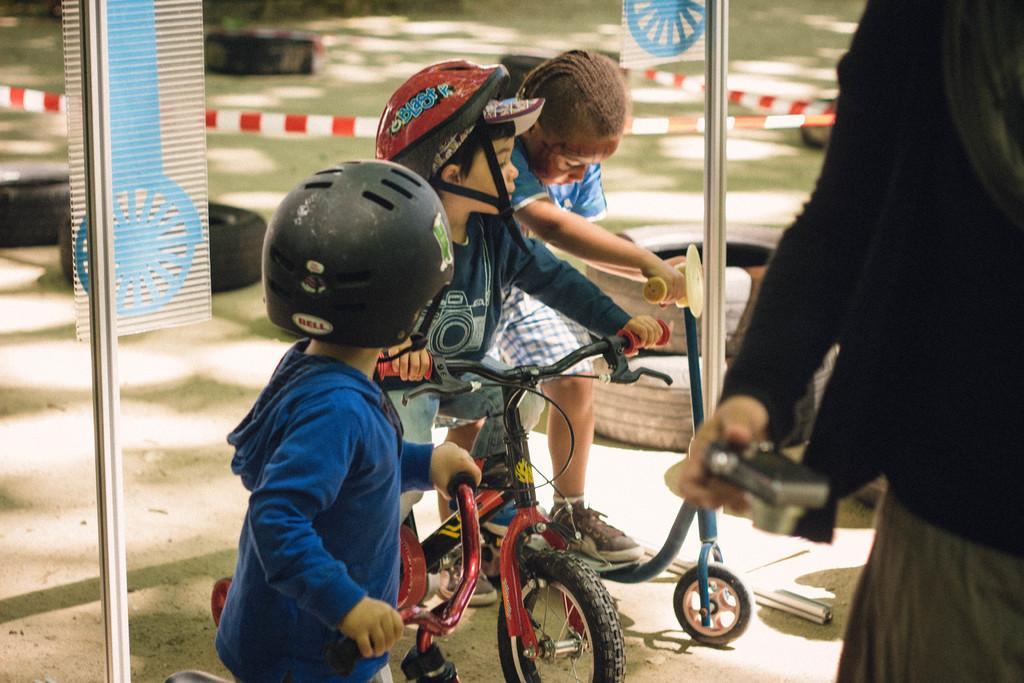How many kids are in the image? There are three kids in the image. What are the kids doing in the image? The kids are with a bicycle. Who else is present in the image besides the kids? There is a person holding a camera in the image. What can be seen in the background of the image? There are tires and rods visible in the background of the image. What type of lip can be seen on the fifth kid in the image? There are only three kids present in the image, and no lips are mentioned or visible. 